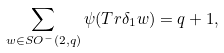Convert formula to latex. <formula><loc_0><loc_0><loc_500><loc_500>\sum _ { w \in S O ^ { - } ( 2 , q ) } \psi ( T r \delta _ { 1 } w ) = q + 1 ,</formula> 